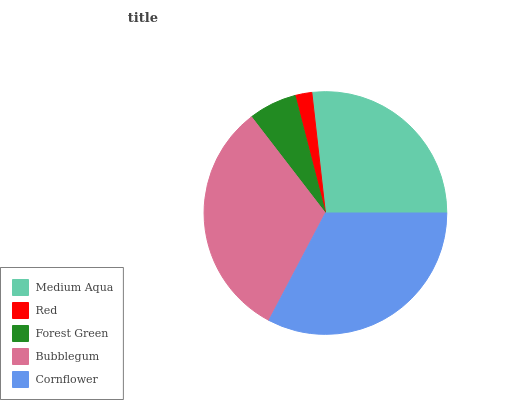Is Red the minimum?
Answer yes or no. Yes. Is Cornflower the maximum?
Answer yes or no. Yes. Is Forest Green the minimum?
Answer yes or no. No. Is Forest Green the maximum?
Answer yes or no. No. Is Forest Green greater than Red?
Answer yes or no. Yes. Is Red less than Forest Green?
Answer yes or no. Yes. Is Red greater than Forest Green?
Answer yes or no. No. Is Forest Green less than Red?
Answer yes or no. No. Is Medium Aqua the high median?
Answer yes or no. Yes. Is Medium Aqua the low median?
Answer yes or no. Yes. Is Red the high median?
Answer yes or no. No. Is Red the low median?
Answer yes or no. No. 